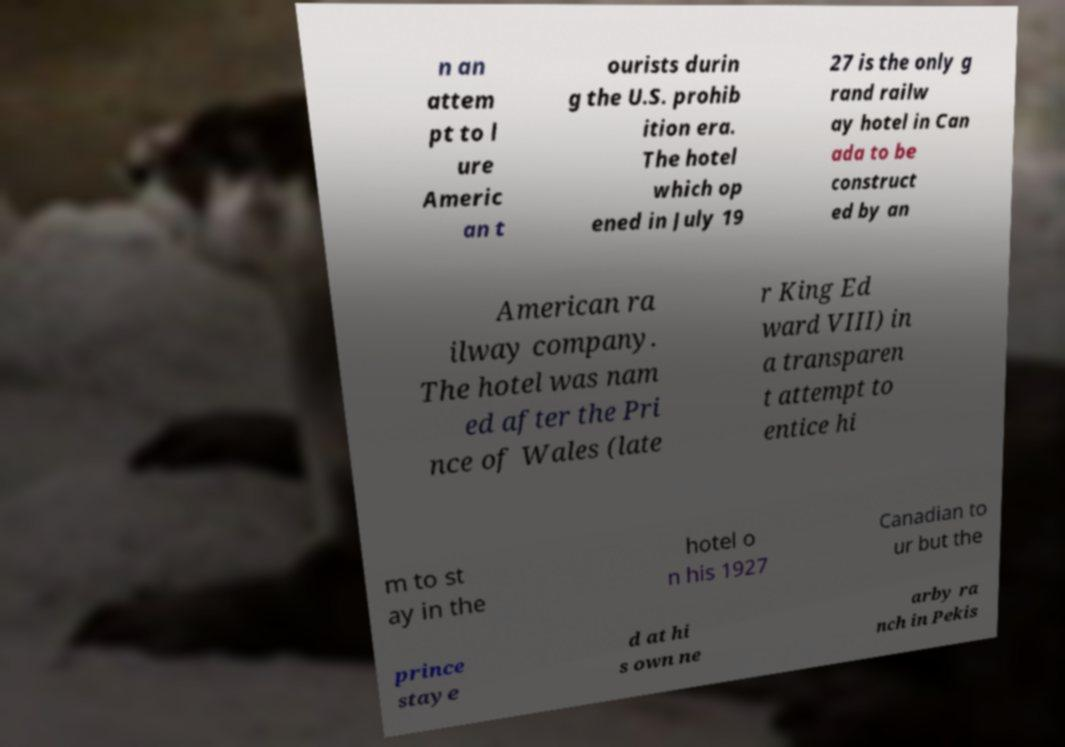I need the written content from this picture converted into text. Can you do that? n an attem pt to l ure Americ an t ourists durin g the U.S. prohib ition era. The hotel which op ened in July 19 27 is the only g rand railw ay hotel in Can ada to be construct ed by an American ra ilway company. The hotel was nam ed after the Pri nce of Wales (late r King Ed ward VIII) in a transparen t attempt to entice hi m to st ay in the hotel o n his 1927 Canadian to ur but the prince staye d at hi s own ne arby ra nch in Pekis 